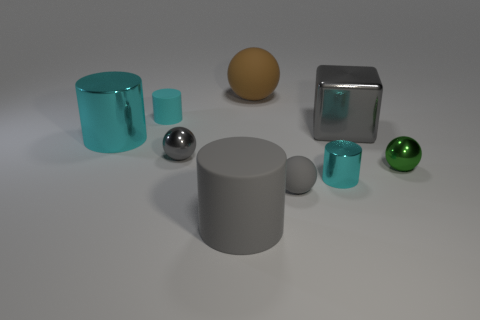There is another gray ball that is the same size as the gray metallic ball; what material is it?
Offer a very short reply. Rubber. How many objects are large gray objects behind the big rubber cylinder or spheres?
Provide a short and direct response. 5. Are there an equal number of metal balls behind the cyan rubber object and brown balls?
Provide a succinct answer. No. Is the small matte ball the same color as the cube?
Give a very brief answer. Yes. The thing that is both in front of the tiny cyan metallic object and to the right of the large brown matte thing is what color?
Keep it short and to the point. Gray. How many cylinders are either big red rubber objects or large cyan metallic objects?
Offer a very short reply. 1. Is the number of big shiny blocks that are left of the big metal cube less than the number of large red metallic balls?
Give a very brief answer. No. The big gray thing that is made of the same material as the green object is what shape?
Provide a succinct answer. Cube. How many other cubes have the same color as the metallic cube?
Offer a very short reply. 0. How many things are either cyan cylinders or small cyan metallic cylinders?
Ensure brevity in your answer.  3. 